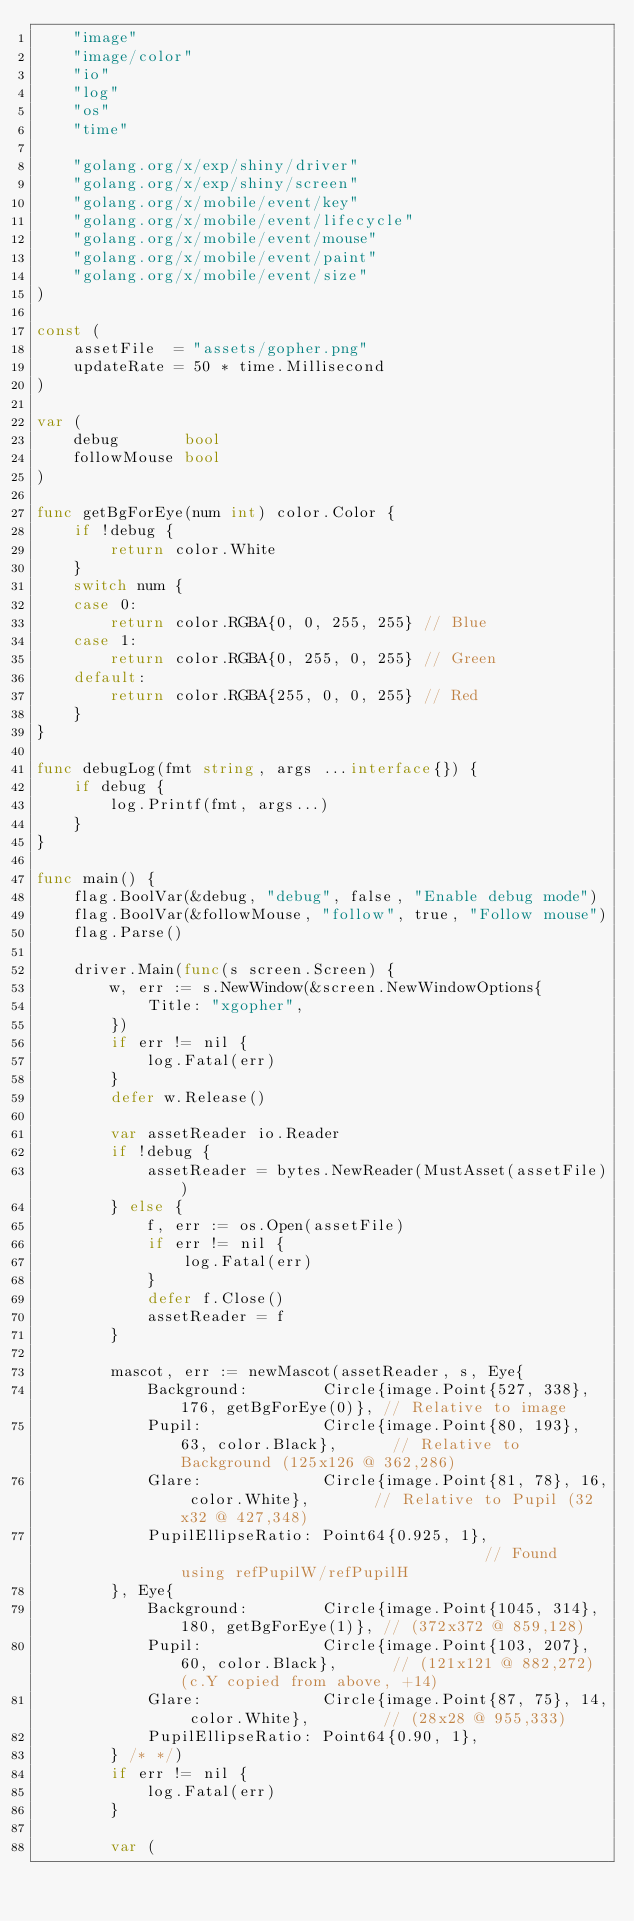<code> <loc_0><loc_0><loc_500><loc_500><_Go_>	"image"
	"image/color"
	"io"
	"log"
	"os"
	"time"

	"golang.org/x/exp/shiny/driver"
	"golang.org/x/exp/shiny/screen"
	"golang.org/x/mobile/event/key"
	"golang.org/x/mobile/event/lifecycle"
	"golang.org/x/mobile/event/mouse"
	"golang.org/x/mobile/event/paint"
	"golang.org/x/mobile/event/size"
)

const (
	assetFile  = "assets/gopher.png"
	updateRate = 50 * time.Millisecond
)

var (
	debug       bool
	followMouse bool
)

func getBgForEye(num int) color.Color {
	if !debug {
		return color.White
	}
	switch num {
	case 0:
		return color.RGBA{0, 0, 255, 255} // Blue
	case 1:
		return color.RGBA{0, 255, 0, 255} // Green
	default:
		return color.RGBA{255, 0, 0, 255} // Red
	}
}

func debugLog(fmt string, args ...interface{}) {
	if debug {
		log.Printf(fmt, args...)
	}
}

func main() {
	flag.BoolVar(&debug, "debug", false, "Enable debug mode")
	flag.BoolVar(&followMouse, "follow", true, "Follow mouse")
	flag.Parse()

	driver.Main(func(s screen.Screen) {
		w, err := s.NewWindow(&screen.NewWindowOptions{
			Title: "xgopher",
		})
		if err != nil {
			log.Fatal(err)
		}
		defer w.Release()

		var assetReader io.Reader
		if !debug {
			assetReader = bytes.NewReader(MustAsset(assetFile))
		} else {
			f, err := os.Open(assetFile)
			if err != nil {
				log.Fatal(err)
			}
			defer f.Close()
			assetReader = f
		}

		mascot, err := newMascot(assetReader, s, Eye{
			Background:        Circle{image.Point{527, 338}, 176, getBgForEye(0)}, // Relative to image
			Pupil:             Circle{image.Point{80, 193}, 63, color.Black},      // Relative to Background (125x126 @ 362,286)
			Glare:             Circle{image.Point{81, 78}, 16, color.White},       // Relative to Pupil (32x32 @ 427,348)
			PupilEllipseRatio: Point64{0.925, 1},                                  // Found using refPupilW/refPupilH
		}, Eye{
			Background:        Circle{image.Point{1045, 314}, 180, getBgForEye(1)}, // (372x372 @ 859,128)
			Pupil:             Circle{image.Point{103, 207}, 60, color.Black},      // (121x121 @ 882,272) (c.Y copied from above, +14)
			Glare:             Circle{image.Point{87, 75}, 14, color.White},        // (28x28 @ 955,333)
			PupilEllipseRatio: Point64{0.90, 1},
		} /* */)
		if err != nil {
			log.Fatal(err)
		}

		var (</code> 